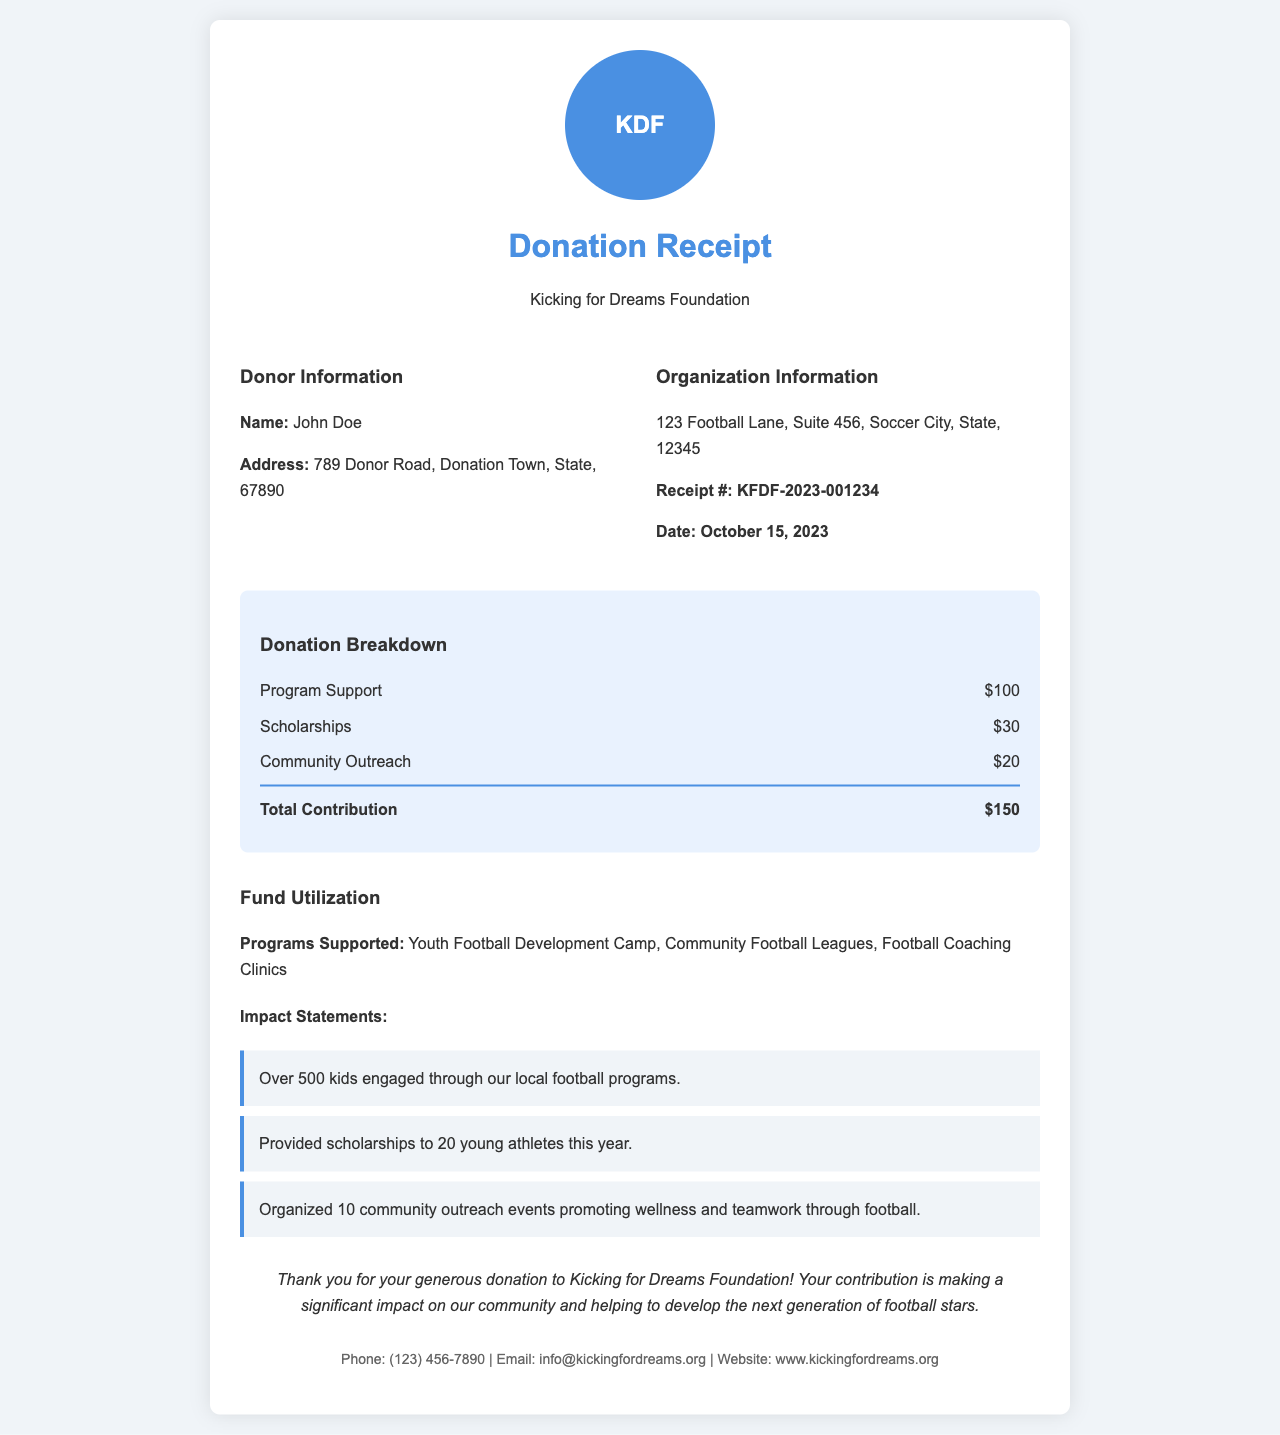What is the name of the donor? The donor's name is listed in the donor information section.
Answer: John Doe What is the total contribution amount? The total contribution is the sum of all the breakdown items.
Answer: $150 What date was the donation made? The donation date is specifically mentioned in the document.
Answer: October 15, 2023 How many scholarships were provided this year? The impact statement mentions the number of scholarships given.
Answer: 20 What is the address of the charity organization? The organization's address is detailed in the organization information section.
Answer: 123 Football Lane, Suite 456, Soccer City, State, 12345 What program received the highest funding? The donation breakdown shows the individual amounts allocated to each program.
Answer: Program Support How many kids engaged through local football programs? The impact statement provides this specific information.
Answer: 500 What is the receipt number? The receipt number is listed in the organization information section.
Answer: KFDF-2023-001234 What phone number can be used for contact? The contact info section lists the charity's phone number.
Answer: (123) 456-7890 